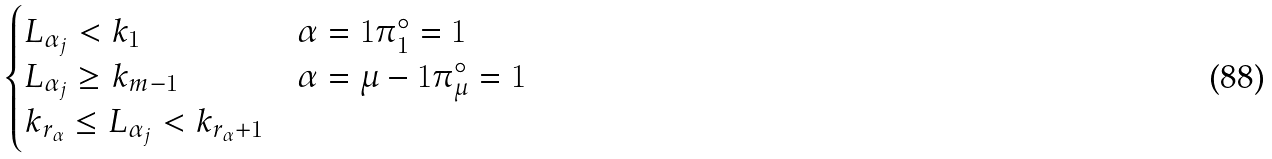Convert formula to latex. <formula><loc_0><loc_0><loc_500><loc_500>\begin{cases} L _ { \alpha _ { j } } < k _ { 1 } & \alpha = 1 \pi _ { 1 } ^ { \circ } = 1 \\ L _ { \alpha _ { j } } \geq k _ { m - 1 } & \alpha = \mu - 1 \pi _ { \mu } ^ { \circ } = 1 \\ k _ { r _ { \alpha } } \leq L _ { \alpha _ { j } } < k _ { r _ { \alpha } + 1 } & \end{cases}</formula> 